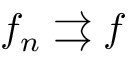Convert formula to latex. <formula><loc_0><loc_0><loc_500><loc_500>f _ { n } \right r i g h t a r r o w s f</formula> 